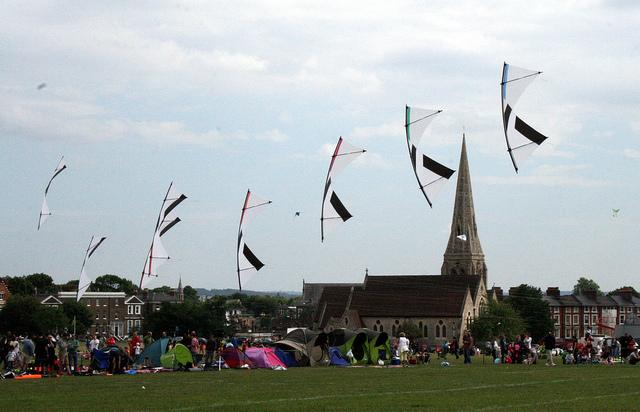What might be taking place in the building to the right?

Choices:
A) baseball game
B) roller derby
C) worship service
D) property auction worship service 